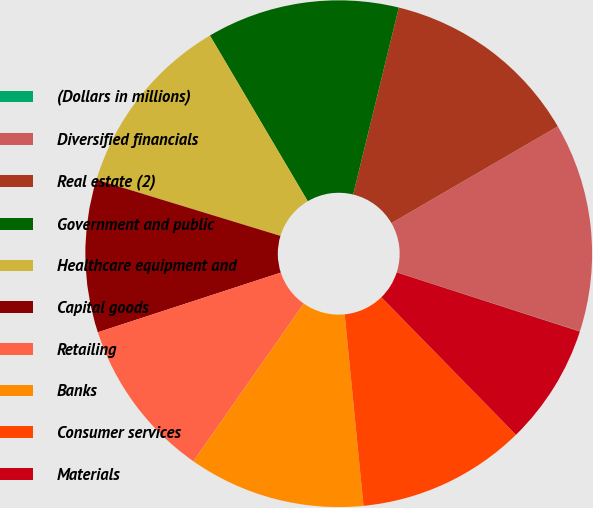Convert chart to OTSL. <chart><loc_0><loc_0><loc_500><loc_500><pie_chart><fcel>(Dollars in millions)<fcel>Diversified financials<fcel>Real estate (2)<fcel>Government and public<fcel>Healthcare equipment and<fcel>Capital goods<fcel>Retailing<fcel>Banks<fcel>Consumer services<fcel>Materials<nl><fcel>0.02%<fcel>13.33%<fcel>12.81%<fcel>12.3%<fcel>11.79%<fcel>9.74%<fcel>10.26%<fcel>11.28%<fcel>10.77%<fcel>7.7%<nl></chart> 